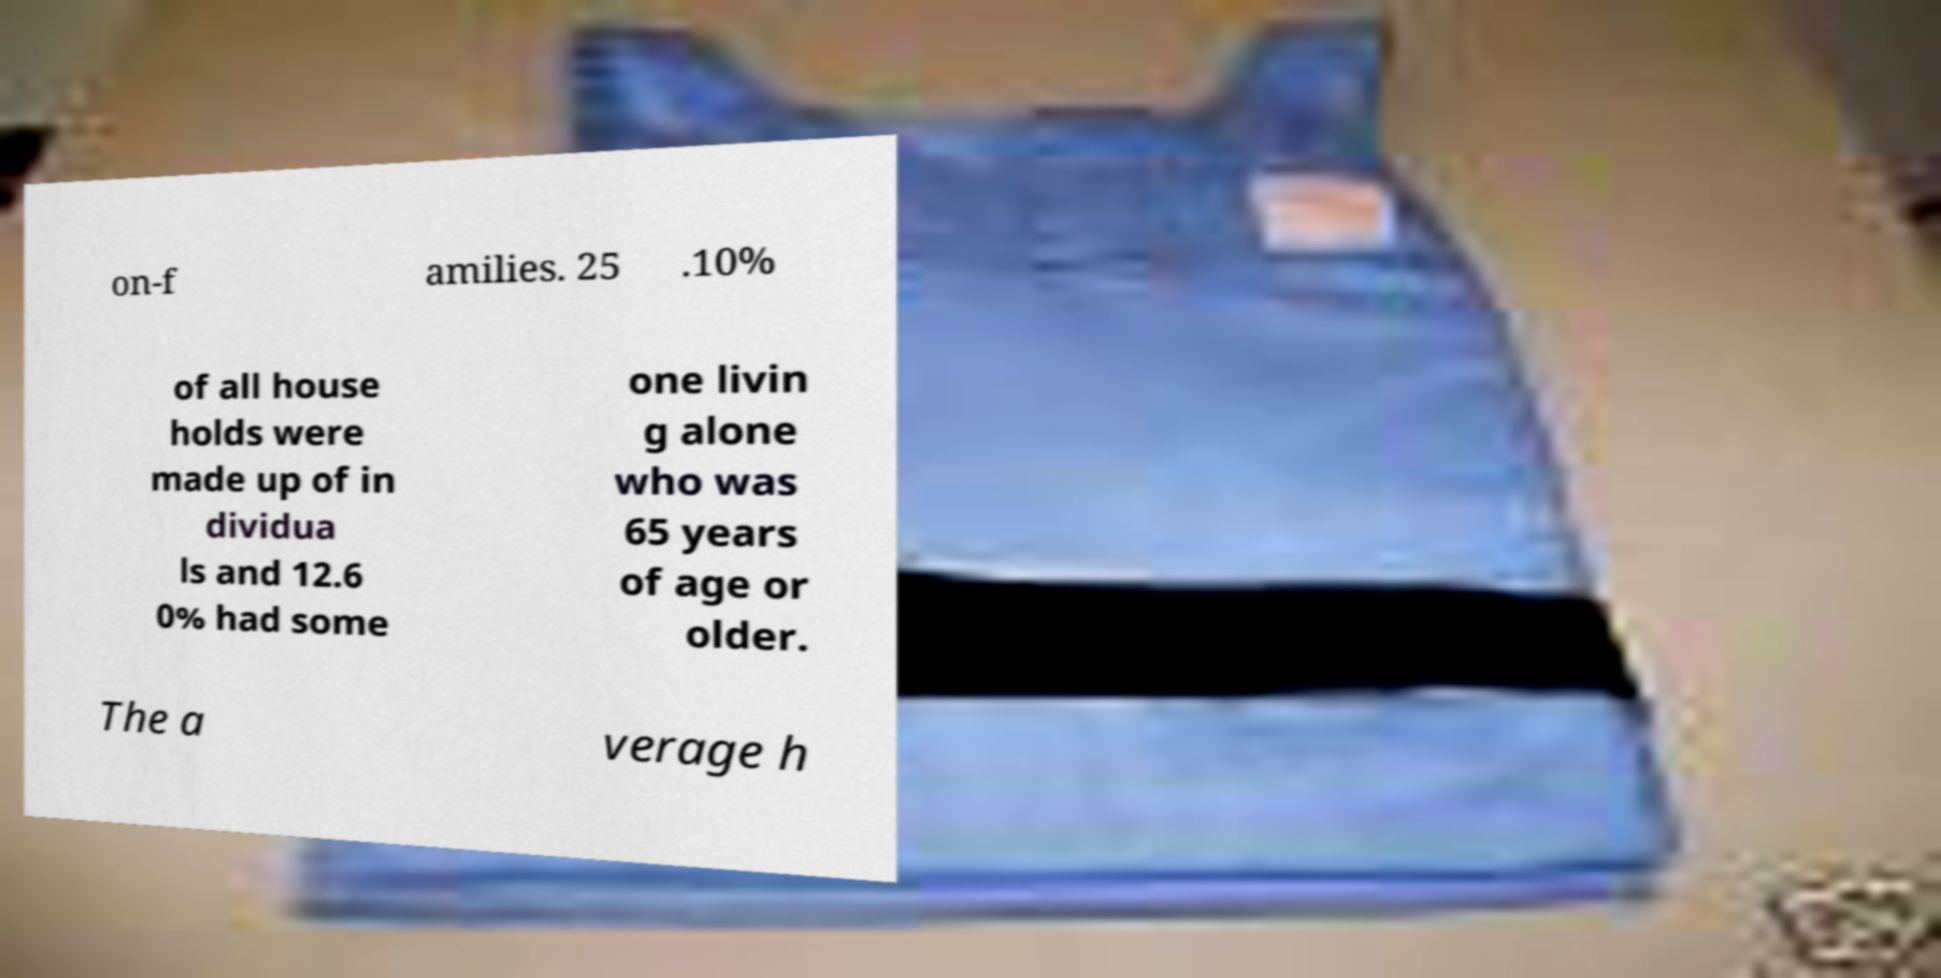Can you accurately transcribe the text from the provided image for me? on-f amilies. 25 .10% of all house holds were made up of in dividua ls and 12.6 0% had some one livin g alone who was 65 years of age or older. The a verage h 